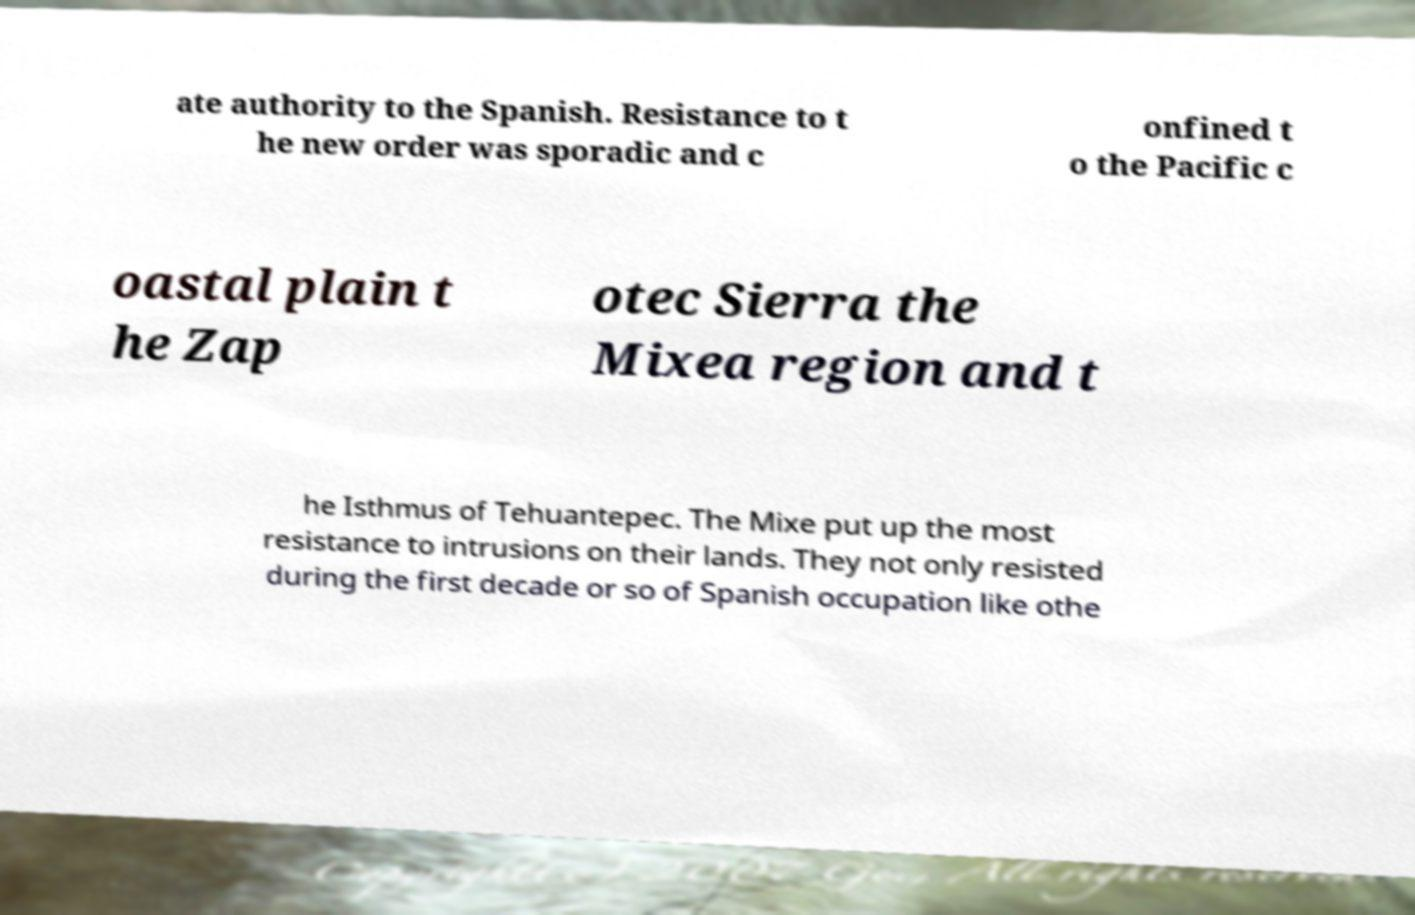Could you extract and type out the text from this image? ate authority to the Spanish. Resistance to t he new order was sporadic and c onfined t o the Pacific c oastal plain t he Zap otec Sierra the Mixea region and t he Isthmus of Tehuantepec. The Mixe put up the most resistance to intrusions on their lands. They not only resisted during the first decade or so of Spanish occupation like othe 